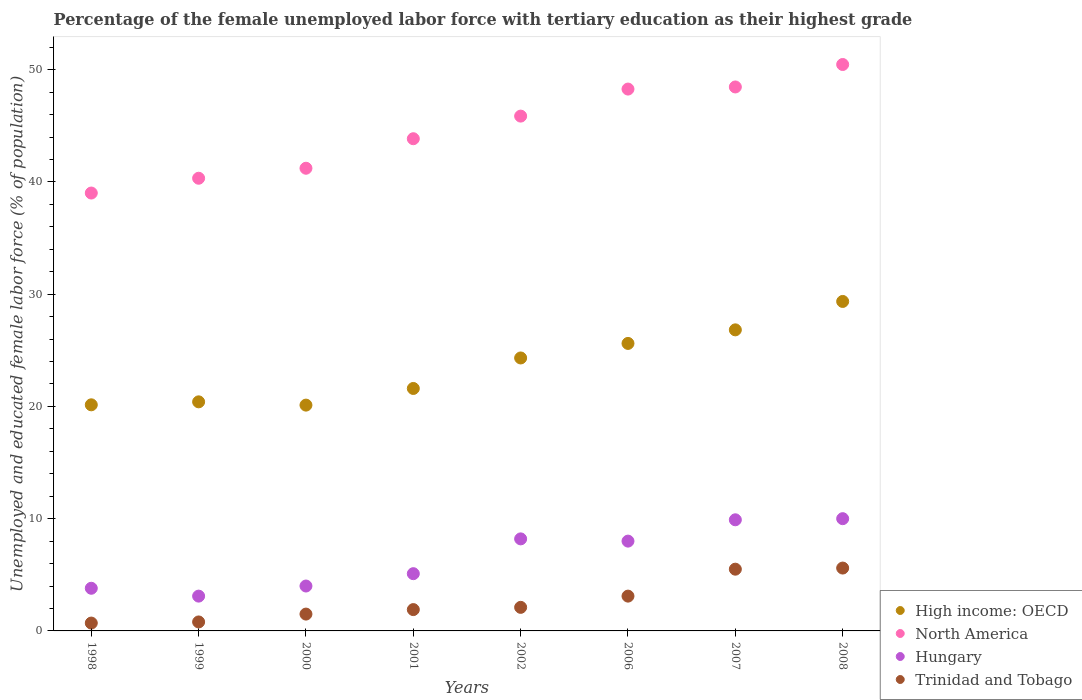How many different coloured dotlines are there?
Keep it short and to the point. 4. What is the percentage of the unemployed female labor force with tertiary education in High income: OECD in 2006?
Make the answer very short. 25.61. Across all years, what is the maximum percentage of the unemployed female labor force with tertiary education in High income: OECD?
Offer a terse response. 29.35. Across all years, what is the minimum percentage of the unemployed female labor force with tertiary education in Trinidad and Tobago?
Keep it short and to the point. 0.7. In which year was the percentage of the unemployed female labor force with tertiary education in Trinidad and Tobago maximum?
Provide a short and direct response. 2008. What is the total percentage of the unemployed female labor force with tertiary education in North America in the graph?
Your response must be concise. 357.46. What is the difference between the percentage of the unemployed female labor force with tertiary education in Trinidad and Tobago in 1998 and that in 2000?
Ensure brevity in your answer.  -0.8. What is the difference between the percentage of the unemployed female labor force with tertiary education in Hungary in 1999 and the percentage of the unemployed female labor force with tertiary education in High income: OECD in 2001?
Your answer should be very brief. -18.5. What is the average percentage of the unemployed female labor force with tertiary education in Trinidad and Tobago per year?
Provide a short and direct response. 2.65. In the year 2007, what is the difference between the percentage of the unemployed female labor force with tertiary education in Hungary and percentage of the unemployed female labor force with tertiary education in North America?
Your answer should be very brief. -38.56. In how many years, is the percentage of the unemployed female labor force with tertiary education in High income: OECD greater than 38 %?
Keep it short and to the point. 0. What is the ratio of the percentage of the unemployed female labor force with tertiary education in North America in 1999 to that in 2001?
Offer a terse response. 0.92. Is the percentage of the unemployed female labor force with tertiary education in North America in 2006 less than that in 2007?
Your answer should be very brief. Yes. What is the difference between the highest and the second highest percentage of the unemployed female labor force with tertiary education in Trinidad and Tobago?
Make the answer very short. 0.1. What is the difference between the highest and the lowest percentage of the unemployed female labor force with tertiary education in North America?
Offer a very short reply. 11.45. Is the sum of the percentage of the unemployed female labor force with tertiary education in Hungary in 2007 and 2008 greater than the maximum percentage of the unemployed female labor force with tertiary education in High income: OECD across all years?
Provide a succinct answer. No. Does the percentage of the unemployed female labor force with tertiary education in North America monotonically increase over the years?
Offer a terse response. Yes. Is the percentage of the unemployed female labor force with tertiary education in Trinidad and Tobago strictly less than the percentage of the unemployed female labor force with tertiary education in North America over the years?
Provide a succinct answer. Yes. What is the difference between two consecutive major ticks on the Y-axis?
Give a very brief answer. 10. Are the values on the major ticks of Y-axis written in scientific E-notation?
Your response must be concise. No. Does the graph contain grids?
Give a very brief answer. No. How many legend labels are there?
Ensure brevity in your answer.  4. What is the title of the graph?
Make the answer very short. Percentage of the female unemployed labor force with tertiary education as their highest grade. Does "Angola" appear as one of the legend labels in the graph?
Keep it short and to the point. No. What is the label or title of the X-axis?
Your response must be concise. Years. What is the label or title of the Y-axis?
Ensure brevity in your answer.  Unemployed and educated female labor force (% of population). What is the Unemployed and educated female labor force (% of population) of High income: OECD in 1998?
Provide a succinct answer. 20.14. What is the Unemployed and educated female labor force (% of population) of North America in 1998?
Make the answer very short. 39.01. What is the Unemployed and educated female labor force (% of population) in Hungary in 1998?
Provide a succinct answer. 3.8. What is the Unemployed and educated female labor force (% of population) in Trinidad and Tobago in 1998?
Give a very brief answer. 0.7. What is the Unemployed and educated female labor force (% of population) in High income: OECD in 1999?
Provide a succinct answer. 20.41. What is the Unemployed and educated female labor force (% of population) in North America in 1999?
Provide a short and direct response. 40.33. What is the Unemployed and educated female labor force (% of population) in Hungary in 1999?
Your answer should be compact. 3.1. What is the Unemployed and educated female labor force (% of population) of Trinidad and Tobago in 1999?
Your response must be concise. 0.8. What is the Unemployed and educated female labor force (% of population) of High income: OECD in 2000?
Offer a very short reply. 20.12. What is the Unemployed and educated female labor force (% of population) of North America in 2000?
Offer a terse response. 41.22. What is the Unemployed and educated female labor force (% of population) in High income: OECD in 2001?
Provide a short and direct response. 21.6. What is the Unemployed and educated female labor force (% of population) of North America in 2001?
Offer a very short reply. 43.85. What is the Unemployed and educated female labor force (% of population) of Hungary in 2001?
Provide a succinct answer. 5.1. What is the Unemployed and educated female labor force (% of population) of Trinidad and Tobago in 2001?
Offer a very short reply. 1.9. What is the Unemployed and educated female labor force (% of population) of High income: OECD in 2002?
Your answer should be compact. 24.32. What is the Unemployed and educated female labor force (% of population) in North America in 2002?
Offer a terse response. 45.86. What is the Unemployed and educated female labor force (% of population) in Hungary in 2002?
Give a very brief answer. 8.2. What is the Unemployed and educated female labor force (% of population) in Trinidad and Tobago in 2002?
Offer a terse response. 2.1. What is the Unemployed and educated female labor force (% of population) of High income: OECD in 2006?
Keep it short and to the point. 25.61. What is the Unemployed and educated female labor force (% of population) of North America in 2006?
Your answer should be compact. 48.27. What is the Unemployed and educated female labor force (% of population) in Trinidad and Tobago in 2006?
Provide a succinct answer. 3.1. What is the Unemployed and educated female labor force (% of population) in High income: OECD in 2007?
Your answer should be very brief. 26.82. What is the Unemployed and educated female labor force (% of population) of North America in 2007?
Your answer should be compact. 48.46. What is the Unemployed and educated female labor force (% of population) of Hungary in 2007?
Offer a very short reply. 9.9. What is the Unemployed and educated female labor force (% of population) in Trinidad and Tobago in 2007?
Your answer should be very brief. 5.5. What is the Unemployed and educated female labor force (% of population) in High income: OECD in 2008?
Give a very brief answer. 29.35. What is the Unemployed and educated female labor force (% of population) in North America in 2008?
Provide a succinct answer. 50.46. What is the Unemployed and educated female labor force (% of population) of Trinidad and Tobago in 2008?
Ensure brevity in your answer.  5.6. Across all years, what is the maximum Unemployed and educated female labor force (% of population) of High income: OECD?
Offer a very short reply. 29.35. Across all years, what is the maximum Unemployed and educated female labor force (% of population) in North America?
Make the answer very short. 50.46. Across all years, what is the maximum Unemployed and educated female labor force (% of population) in Hungary?
Provide a short and direct response. 10. Across all years, what is the maximum Unemployed and educated female labor force (% of population) of Trinidad and Tobago?
Offer a very short reply. 5.6. Across all years, what is the minimum Unemployed and educated female labor force (% of population) of High income: OECD?
Provide a short and direct response. 20.12. Across all years, what is the minimum Unemployed and educated female labor force (% of population) in North America?
Give a very brief answer. 39.01. Across all years, what is the minimum Unemployed and educated female labor force (% of population) of Hungary?
Make the answer very short. 3.1. Across all years, what is the minimum Unemployed and educated female labor force (% of population) of Trinidad and Tobago?
Offer a terse response. 0.7. What is the total Unemployed and educated female labor force (% of population) of High income: OECD in the graph?
Your answer should be compact. 188.37. What is the total Unemployed and educated female labor force (% of population) of North America in the graph?
Give a very brief answer. 357.46. What is the total Unemployed and educated female labor force (% of population) of Hungary in the graph?
Your answer should be very brief. 52.1. What is the total Unemployed and educated female labor force (% of population) of Trinidad and Tobago in the graph?
Ensure brevity in your answer.  21.2. What is the difference between the Unemployed and educated female labor force (% of population) in High income: OECD in 1998 and that in 1999?
Offer a terse response. -0.27. What is the difference between the Unemployed and educated female labor force (% of population) in North America in 1998 and that in 1999?
Give a very brief answer. -1.32. What is the difference between the Unemployed and educated female labor force (% of population) of Hungary in 1998 and that in 1999?
Provide a succinct answer. 0.7. What is the difference between the Unemployed and educated female labor force (% of population) of High income: OECD in 1998 and that in 2000?
Provide a short and direct response. 0.03. What is the difference between the Unemployed and educated female labor force (% of population) in North America in 1998 and that in 2000?
Ensure brevity in your answer.  -2.21. What is the difference between the Unemployed and educated female labor force (% of population) of Trinidad and Tobago in 1998 and that in 2000?
Offer a very short reply. -0.8. What is the difference between the Unemployed and educated female labor force (% of population) in High income: OECD in 1998 and that in 2001?
Ensure brevity in your answer.  -1.46. What is the difference between the Unemployed and educated female labor force (% of population) of North America in 1998 and that in 2001?
Provide a short and direct response. -4.84. What is the difference between the Unemployed and educated female labor force (% of population) in Hungary in 1998 and that in 2001?
Your answer should be compact. -1.3. What is the difference between the Unemployed and educated female labor force (% of population) of High income: OECD in 1998 and that in 2002?
Your response must be concise. -4.17. What is the difference between the Unemployed and educated female labor force (% of population) of North America in 1998 and that in 2002?
Make the answer very short. -6.85. What is the difference between the Unemployed and educated female labor force (% of population) of Hungary in 1998 and that in 2002?
Offer a terse response. -4.4. What is the difference between the Unemployed and educated female labor force (% of population) in Trinidad and Tobago in 1998 and that in 2002?
Offer a very short reply. -1.4. What is the difference between the Unemployed and educated female labor force (% of population) of High income: OECD in 1998 and that in 2006?
Your answer should be compact. -5.47. What is the difference between the Unemployed and educated female labor force (% of population) in North America in 1998 and that in 2006?
Offer a terse response. -9.26. What is the difference between the Unemployed and educated female labor force (% of population) in High income: OECD in 1998 and that in 2007?
Keep it short and to the point. -6.68. What is the difference between the Unemployed and educated female labor force (% of population) of North America in 1998 and that in 2007?
Give a very brief answer. -9.45. What is the difference between the Unemployed and educated female labor force (% of population) of Trinidad and Tobago in 1998 and that in 2007?
Provide a succinct answer. -4.8. What is the difference between the Unemployed and educated female labor force (% of population) of High income: OECD in 1998 and that in 2008?
Make the answer very short. -9.21. What is the difference between the Unemployed and educated female labor force (% of population) of North America in 1998 and that in 2008?
Your answer should be compact. -11.45. What is the difference between the Unemployed and educated female labor force (% of population) in High income: OECD in 1999 and that in 2000?
Your answer should be very brief. 0.29. What is the difference between the Unemployed and educated female labor force (% of population) of North America in 1999 and that in 2000?
Provide a succinct answer. -0.89. What is the difference between the Unemployed and educated female labor force (% of population) in Hungary in 1999 and that in 2000?
Provide a succinct answer. -0.9. What is the difference between the Unemployed and educated female labor force (% of population) in High income: OECD in 1999 and that in 2001?
Provide a succinct answer. -1.19. What is the difference between the Unemployed and educated female labor force (% of population) in North America in 1999 and that in 2001?
Provide a short and direct response. -3.52. What is the difference between the Unemployed and educated female labor force (% of population) of Trinidad and Tobago in 1999 and that in 2001?
Make the answer very short. -1.1. What is the difference between the Unemployed and educated female labor force (% of population) in High income: OECD in 1999 and that in 2002?
Your response must be concise. -3.91. What is the difference between the Unemployed and educated female labor force (% of population) of North America in 1999 and that in 2002?
Offer a terse response. -5.54. What is the difference between the Unemployed and educated female labor force (% of population) of Trinidad and Tobago in 1999 and that in 2002?
Provide a short and direct response. -1.3. What is the difference between the Unemployed and educated female labor force (% of population) of High income: OECD in 1999 and that in 2006?
Provide a succinct answer. -5.2. What is the difference between the Unemployed and educated female labor force (% of population) in North America in 1999 and that in 2006?
Make the answer very short. -7.94. What is the difference between the Unemployed and educated female labor force (% of population) in High income: OECD in 1999 and that in 2007?
Offer a very short reply. -6.41. What is the difference between the Unemployed and educated female labor force (% of population) in North America in 1999 and that in 2007?
Make the answer very short. -8.13. What is the difference between the Unemployed and educated female labor force (% of population) in Hungary in 1999 and that in 2007?
Make the answer very short. -6.8. What is the difference between the Unemployed and educated female labor force (% of population) of Trinidad and Tobago in 1999 and that in 2007?
Provide a succinct answer. -4.7. What is the difference between the Unemployed and educated female labor force (% of population) in High income: OECD in 1999 and that in 2008?
Your response must be concise. -8.94. What is the difference between the Unemployed and educated female labor force (% of population) of North America in 1999 and that in 2008?
Offer a terse response. -10.13. What is the difference between the Unemployed and educated female labor force (% of population) of Hungary in 1999 and that in 2008?
Give a very brief answer. -6.9. What is the difference between the Unemployed and educated female labor force (% of population) of High income: OECD in 2000 and that in 2001?
Your answer should be very brief. -1.48. What is the difference between the Unemployed and educated female labor force (% of population) of North America in 2000 and that in 2001?
Keep it short and to the point. -2.63. What is the difference between the Unemployed and educated female labor force (% of population) of Hungary in 2000 and that in 2001?
Provide a succinct answer. -1.1. What is the difference between the Unemployed and educated female labor force (% of population) of Trinidad and Tobago in 2000 and that in 2001?
Provide a short and direct response. -0.4. What is the difference between the Unemployed and educated female labor force (% of population) of High income: OECD in 2000 and that in 2002?
Your response must be concise. -4.2. What is the difference between the Unemployed and educated female labor force (% of population) of North America in 2000 and that in 2002?
Your response must be concise. -4.65. What is the difference between the Unemployed and educated female labor force (% of population) of High income: OECD in 2000 and that in 2006?
Keep it short and to the point. -5.5. What is the difference between the Unemployed and educated female labor force (% of population) in North America in 2000 and that in 2006?
Give a very brief answer. -7.05. What is the difference between the Unemployed and educated female labor force (% of population) of Hungary in 2000 and that in 2006?
Provide a short and direct response. -4. What is the difference between the Unemployed and educated female labor force (% of population) of Trinidad and Tobago in 2000 and that in 2006?
Provide a short and direct response. -1.6. What is the difference between the Unemployed and educated female labor force (% of population) of High income: OECD in 2000 and that in 2007?
Offer a terse response. -6.71. What is the difference between the Unemployed and educated female labor force (% of population) in North America in 2000 and that in 2007?
Provide a succinct answer. -7.24. What is the difference between the Unemployed and educated female labor force (% of population) of Hungary in 2000 and that in 2007?
Make the answer very short. -5.9. What is the difference between the Unemployed and educated female labor force (% of population) of Trinidad and Tobago in 2000 and that in 2007?
Offer a terse response. -4. What is the difference between the Unemployed and educated female labor force (% of population) in High income: OECD in 2000 and that in 2008?
Give a very brief answer. -9.24. What is the difference between the Unemployed and educated female labor force (% of population) in North America in 2000 and that in 2008?
Keep it short and to the point. -9.24. What is the difference between the Unemployed and educated female labor force (% of population) in Hungary in 2000 and that in 2008?
Keep it short and to the point. -6. What is the difference between the Unemployed and educated female labor force (% of population) of High income: OECD in 2001 and that in 2002?
Keep it short and to the point. -2.72. What is the difference between the Unemployed and educated female labor force (% of population) in North America in 2001 and that in 2002?
Provide a short and direct response. -2.01. What is the difference between the Unemployed and educated female labor force (% of population) of Hungary in 2001 and that in 2002?
Your answer should be very brief. -3.1. What is the difference between the Unemployed and educated female labor force (% of population) in High income: OECD in 2001 and that in 2006?
Offer a terse response. -4.01. What is the difference between the Unemployed and educated female labor force (% of population) of North America in 2001 and that in 2006?
Keep it short and to the point. -4.42. What is the difference between the Unemployed and educated female labor force (% of population) in Trinidad and Tobago in 2001 and that in 2006?
Give a very brief answer. -1.2. What is the difference between the Unemployed and educated female labor force (% of population) of High income: OECD in 2001 and that in 2007?
Provide a short and direct response. -5.22. What is the difference between the Unemployed and educated female labor force (% of population) of North America in 2001 and that in 2007?
Keep it short and to the point. -4.61. What is the difference between the Unemployed and educated female labor force (% of population) in Hungary in 2001 and that in 2007?
Keep it short and to the point. -4.8. What is the difference between the Unemployed and educated female labor force (% of population) in High income: OECD in 2001 and that in 2008?
Give a very brief answer. -7.75. What is the difference between the Unemployed and educated female labor force (% of population) in North America in 2001 and that in 2008?
Your answer should be compact. -6.61. What is the difference between the Unemployed and educated female labor force (% of population) in Hungary in 2001 and that in 2008?
Your answer should be very brief. -4.9. What is the difference between the Unemployed and educated female labor force (% of population) of Trinidad and Tobago in 2001 and that in 2008?
Provide a short and direct response. -3.7. What is the difference between the Unemployed and educated female labor force (% of population) of High income: OECD in 2002 and that in 2006?
Give a very brief answer. -1.3. What is the difference between the Unemployed and educated female labor force (% of population) of North America in 2002 and that in 2006?
Provide a short and direct response. -2.41. What is the difference between the Unemployed and educated female labor force (% of population) in Trinidad and Tobago in 2002 and that in 2006?
Offer a very short reply. -1. What is the difference between the Unemployed and educated female labor force (% of population) of High income: OECD in 2002 and that in 2007?
Make the answer very short. -2.5. What is the difference between the Unemployed and educated female labor force (% of population) in North America in 2002 and that in 2007?
Offer a terse response. -2.6. What is the difference between the Unemployed and educated female labor force (% of population) in Hungary in 2002 and that in 2007?
Your answer should be very brief. -1.7. What is the difference between the Unemployed and educated female labor force (% of population) in High income: OECD in 2002 and that in 2008?
Keep it short and to the point. -5.03. What is the difference between the Unemployed and educated female labor force (% of population) of North America in 2002 and that in 2008?
Keep it short and to the point. -4.6. What is the difference between the Unemployed and educated female labor force (% of population) in Hungary in 2002 and that in 2008?
Keep it short and to the point. -1.8. What is the difference between the Unemployed and educated female labor force (% of population) in Trinidad and Tobago in 2002 and that in 2008?
Offer a terse response. -3.5. What is the difference between the Unemployed and educated female labor force (% of population) of High income: OECD in 2006 and that in 2007?
Ensure brevity in your answer.  -1.21. What is the difference between the Unemployed and educated female labor force (% of population) in North America in 2006 and that in 2007?
Your response must be concise. -0.19. What is the difference between the Unemployed and educated female labor force (% of population) in Hungary in 2006 and that in 2007?
Your response must be concise. -1.9. What is the difference between the Unemployed and educated female labor force (% of population) of High income: OECD in 2006 and that in 2008?
Make the answer very short. -3.74. What is the difference between the Unemployed and educated female labor force (% of population) of North America in 2006 and that in 2008?
Ensure brevity in your answer.  -2.19. What is the difference between the Unemployed and educated female labor force (% of population) of Hungary in 2006 and that in 2008?
Give a very brief answer. -2. What is the difference between the Unemployed and educated female labor force (% of population) in Trinidad and Tobago in 2006 and that in 2008?
Offer a very short reply. -2.5. What is the difference between the Unemployed and educated female labor force (% of population) of High income: OECD in 2007 and that in 2008?
Ensure brevity in your answer.  -2.53. What is the difference between the Unemployed and educated female labor force (% of population) of North America in 2007 and that in 2008?
Keep it short and to the point. -2. What is the difference between the Unemployed and educated female labor force (% of population) in Trinidad and Tobago in 2007 and that in 2008?
Provide a short and direct response. -0.1. What is the difference between the Unemployed and educated female labor force (% of population) in High income: OECD in 1998 and the Unemployed and educated female labor force (% of population) in North America in 1999?
Give a very brief answer. -20.18. What is the difference between the Unemployed and educated female labor force (% of population) of High income: OECD in 1998 and the Unemployed and educated female labor force (% of population) of Hungary in 1999?
Your answer should be compact. 17.04. What is the difference between the Unemployed and educated female labor force (% of population) in High income: OECD in 1998 and the Unemployed and educated female labor force (% of population) in Trinidad and Tobago in 1999?
Provide a short and direct response. 19.34. What is the difference between the Unemployed and educated female labor force (% of population) in North America in 1998 and the Unemployed and educated female labor force (% of population) in Hungary in 1999?
Offer a terse response. 35.91. What is the difference between the Unemployed and educated female labor force (% of population) in North America in 1998 and the Unemployed and educated female labor force (% of population) in Trinidad and Tobago in 1999?
Give a very brief answer. 38.21. What is the difference between the Unemployed and educated female labor force (% of population) of High income: OECD in 1998 and the Unemployed and educated female labor force (% of population) of North America in 2000?
Offer a terse response. -21.08. What is the difference between the Unemployed and educated female labor force (% of population) of High income: OECD in 1998 and the Unemployed and educated female labor force (% of population) of Hungary in 2000?
Make the answer very short. 16.14. What is the difference between the Unemployed and educated female labor force (% of population) of High income: OECD in 1998 and the Unemployed and educated female labor force (% of population) of Trinidad and Tobago in 2000?
Offer a very short reply. 18.64. What is the difference between the Unemployed and educated female labor force (% of population) in North America in 1998 and the Unemployed and educated female labor force (% of population) in Hungary in 2000?
Keep it short and to the point. 35.01. What is the difference between the Unemployed and educated female labor force (% of population) in North America in 1998 and the Unemployed and educated female labor force (% of population) in Trinidad and Tobago in 2000?
Provide a succinct answer. 37.51. What is the difference between the Unemployed and educated female labor force (% of population) of Hungary in 1998 and the Unemployed and educated female labor force (% of population) of Trinidad and Tobago in 2000?
Ensure brevity in your answer.  2.3. What is the difference between the Unemployed and educated female labor force (% of population) in High income: OECD in 1998 and the Unemployed and educated female labor force (% of population) in North America in 2001?
Your answer should be very brief. -23.71. What is the difference between the Unemployed and educated female labor force (% of population) of High income: OECD in 1998 and the Unemployed and educated female labor force (% of population) of Hungary in 2001?
Give a very brief answer. 15.04. What is the difference between the Unemployed and educated female labor force (% of population) in High income: OECD in 1998 and the Unemployed and educated female labor force (% of population) in Trinidad and Tobago in 2001?
Offer a very short reply. 18.24. What is the difference between the Unemployed and educated female labor force (% of population) in North America in 1998 and the Unemployed and educated female labor force (% of population) in Hungary in 2001?
Provide a short and direct response. 33.91. What is the difference between the Unemployed and educated female labor force (% of population) of North America in 1998 and the Unemployed and educated female labor force (% of population) of Trinidad and Tobago in 2001?
Offer a very short reply. 37.11. What is the difference between the Unemployed and educated female labor force (% of population) of High income: OECD in 1998 and the Unemployed and educated female labor force (% of population) of North America in 2002?
Keep it short and to the point. -25.72. What is the difference between the Unemployed and educated female labor force (% of population) of High income: OECD in 1998 and the Unemployed and educated female labor force (% of population) of Hungary in 2002?
Provide a succinct answer. 11.94. What is the difference between the Unemployed and educated female labor force (% of population) of High income: OECD in 1998 and the Unemployed and educated female labor force (% of population) of Trinidad and Tobago in 2002?
Provide a short and direct response. 18.04. What is the difference between the Unemployed and educated female labor force (% of population) of North America in 1998 and the Unemployed and educated female labor force (% of population) of Hungary in 2002?
Provide a short and direct response. 30.81. What is the difference between the Unemployed and educated female labor force (% of population) of North America in 1998 and the Unemployed and educated female labor force (% of population) of Trinidad and Tobago in 2002?
Provide a succinct answer. 36.91. What is the difference between the Unemployed and educated female labor force (% of population) of High income: OECD in 1998 and the Unemployed and educated female labor force (% of population) of North America in 2006?
Keep it short and to the point. -28.13. What is the difference between the Unemployed and educated female labor force (% of population) of High income: OECD in 1998 and the Unemployed and educated female labor force (% of population) of Hungary in 2006?
Give a very brief answer. 12.14. What is the difference between the Unemployed and educated female labor force (% of population) in High income: OECD in 1998 and the Unemployed and educated female labor force (% of population) in Trinidad and Tobago in 2006?
Ensure brevity in your answer.  17.04. What is the difference between the Unemployed and educated female labor force (% of population) in North America in 1998 and the Unemployed and educated female labor force (% of population) in Hungary in 2006?
Provide a short and direct response. 31.01. What is the difference between the Unemployed and educated female labor force (% of population) of North America in 1998 and the Unemployed and educated female labor force (% of population) of Trinidad and Tobago in 2006?
Make the answer very short. 35.91. What is the difference between the Unemployed and educated female labor force (% of population) in Hungary in 1998 and the Unemployed and educated female labor force (% of population) in Trinidad and Tobago in 2006?
Make the answer very short. 0.7. What is the difference between the Unemployed and educated female labor force (% of population) in High income: OECD in 1998 and the Unemployed and educated female labor force (% of population) in North America in 2007?
Ensure brevity in your answer.  -28.32. What is the difference between the Unemployed and educated female labor force (% of population) in High income: OECD in 1998 and the Unemployed and educated female labor force (% of population) in Hungary in 2007?
Make the answer very short. 10.24. What is the difference between the Unemployed and educated female labor force (% of population) of High income: OECD in 1998 and the Unemployed and educated female labor force (% of population) of Trinidad and Tobago in 2007?
Provide a short and direct response. 14.64. What is the difference between the Unemployed and educated female labor force (% of population) of North America in 1998 and the Unemployed and educated female labor force (% of population) of Hungary in 2007?
Ensure brevity in your answer.  29.11. What is the difference between the Unemployed and educated female labor force (% of population) of North America in 1998 and the Unemployed and educated female labor force (% of population) of Trinidad and Tobago in 2007?
Provide a short and direct response. 33.51. What is the difference between the Unemployed and educated female labor force (% of population) of Hungary in 1998 and the Unemployed and educated female labor force (% of population) of Trinidad and Tobago in 2007?
Keep it short and to the point. -1.7. What is the difference between the Unemployed and educated female labor force (% of population) of High income: OECD in 1998 and the Unemployed and educated female labor force (% of population) of North America in 2008?
Your answer should be compact. -30.32. What is the difference between the Unemployed and educated female labor force (% of population) in High income: OECD in 1998 and the Unemployed and educated female labor force (% of population) in Hungary in 2008?
Give a very brief answer. 10.14. What is the difference between the Unemployed and educated female labor force (% of population) of High income: OECD in 1998 and the Unemployed and educated female labor force (% of population) of Trinidad and Tobago in 2008?
Offer a terse response. 14.54. What is the difference between the Unemployed and educated female labor force (% of population) in North America in 1998 and the Unemployed and educated female labor force (% of population) in Hungary in 2008?
Make the answer very short. 29.01. What is the difference between the Unemployed and educated female labor force (% of population) in North America in 1998 and the Unemployed and educated female labor force (% of population) in Trinidad and Tobago in 2008?
Keep it short and to the point. 33.41. What is the difference between the Unemployed and educated female labor force (% of population) in High income: OECD in 1999 and the Unemployed and educated female labor force (% of population) in North America in 2000?
Keep it short and to the point. -20.81. What is the difference between the Unemployed and educated female labor force (% of population) in High income: OECD in 1999 and the Unemployed and educated female labor force (% of population) in Hungary in 2000?
Your answer should be very brief. 16.41. What is the difference between the Unemployed and educated female labor force (% of population) of High income: OECD in 1999 and the Unemployed and educated female labor force (% of population) of Trinidad and Tobago in 2000?
Ensure brevity in your answer.  18.91. What is the difference between the Unemployed and educated female labor force (% of population) in North America in 1999 and the Unemployed and educated female labor force (% of population) in Hungary in 2000?
Keep it short and to the point. 36.33. What is the difference between the Unemployed and educated female labor force (% of population) of North America in 1999 and the Unemployed and educated female labor force (% of population) of Trinidad and Tobago in 2000?
Your answer should be very brief. 38.83. What is the difference between the Unemployed and educated female labor force (% of population) of Hungary in 1999 and the Unemployed and educated female labor force (% of population) of Trinidad and Tobago in 2000?
Give a very brief answer. 1.6. What is the difference between the Unemployed and educated female labor force (% of population) of High income: OECD in 1999 and the Unemployed and educated female labor force (% of population) of North America in 2001?
Keep it short and to the point. -23.44. What is the difference between the Unemployed and educated female labor force (% of population) of High income: OECD in 1999 and the Unemployed and educated female labor force (% of population) of Hungary in 2001?
Keep it short and to the point. 15.31. What is the difference between the Unemployed and educated female labor force (% of population) in High income: OECD in 1999 and the Unemployed and educated female labor force (% of population) in Trinidad and Tobago in 2001?
Your answer should be compact. 18.51. What is the difference between the Unemployed and educated female labor force (% of population) in North America in 1999 and the Unemployed and educated female labor force (% of population) in Hungary in 2001?
Provide a short and direct response. 35.23. What is the difference between the Unemployed and educated female labor force (% of population) of North America in 1999 and the Unemployed and educated female labor force (% of population) of Trinidad and Tobago in 2001?
Keep it short and to the point. 38.43. What is the difference between the Unemployed and educated female labor force (% of population) of High income: OECD in 1999 and the Unemployed and educated female labor force (% of population) of North America in 2002?
Provide a short and direct response. -25.46. What is the difference between the Unemployed and educated female labor force (% of population) in High income: OECD in 1999 and the Unemployed and educated female labor force (% of population) in Hungary in 2002?
Offer a very short reply. 12.21. What is the difference between the Unemployed and educated female labor force (% of population) of High income: OECD in 1999 and the Unemployed and educated female labor force (% of population) of Trinidad and Tobago in 2002?
Your answer should be very brief. 18.31. What is the difference between the Unemployed and educated female labor force (% of population) in North America in 1999 and the Unemployed and educated female labor force (% of population) in Hungary in 2002?
Your answer should be very brief. 32.13. What is the difference between the Unemployed and educated female labor force (% of population) of North America in 1999 and the Unemployed and educated female labor force (% of population) of Trinidad and Tobago in 2002?
Your response must be concise. 38.23. What is the difference between the Unemployed and educated female labor force (% of population) in High income: OECD in 1999 and the Unemployed and educated female labor force (% of population) in North America in 2006?
Provide a succinct answer. -27.86. What is the difference between the Unemployed and educated female labor force (% of population) in High income: OECD in 1999 and the Unemployed and educated female labor force (% of population) in Hungary in 2006?
Ensure brevity in your answer.  12.41. What is the difference between the Unemployed and educated female labor force (% of population) in High income: OECD in 1999 and the Unemployed and educated female labor force (% of population) in Trinidad and Tobago in 2006?
Your response must be concise. 17.31. What is the difference between the Unemployed and educated female labor force (% of population) of North America in 1999 and the Unemployed and educated female labor force (% of population) of Hungary in 2006?
Keep it short and to the point. 32.33. What is the difference between the Unemployed and educated female labor force (% of population) in North America in 1999 and the Unemployed and educated female labor force (% of population) in Trinidad and Tobago in 2006?
Offer a terse response. 37.23. What is the difference between the Unemployed and educated female labor force (% of population) in High income: OECD in 1999 and the Unemployed and educated female labor force (% of population) in North America in 2007?
Offer a terse response. -28.05. What is the difference between the Unemployed and educated female labor force (% of population) of High income: OECD in 1999 and the Unemployed and educated female labor force (% of population) of Hungary in 2007?
Ensure brevity in your answer.  10.51. What is the difference between the Unemployed and educated female labor force (% of population) in High income: OECD in 1999 and the Unemployed and educated female labor force (% of population) in Trinidad and Tobago in 2007?
Your response must be concise. 14.91. What is the difference between the Unemployed and educated female labor force (% of population) of North America in 1999 and the Unemployed and educated female labor force (% of population) of Hungary in 2007?
Make the answer very short. 30.43. What is the difference between the Unemployed and educated female labor force (% of population) in North America in 1999 and the Unemployed and educated female labor force (% of population) in Trinidad and Tobago in 2007?
Offer a very short reply. 34.83. What is the difference between the Unemployed and educated female labor force (% of population) of High income: OECD in 1999 and the Unemployed and educated female labor force (% of population) of North America in 2008?
Keep it short and to the point. -30.05. What is the difference between the Unemployed and educated female labor force (% of population) in High income: OECD in 1999 and the Unemployed and educated female labor force (% of population) in Hungary in 2008?
Your response must be concise. 10.41. What is the difference between the Unemployed and educated female labor force (% of population) in High income: OECD in 1999 and the Unemployed and educated female labor force (% of population) in Trinidad and Tobago in 2008?
Offer a terse response. 14.81. What is the difference between the Unemployed and educated female labor force (% of population) of North America in 1999 and the Unemployed and educated female labor force (% of population) of Hungary in 2008?
Provide a succinct answer. 30.33. What is the difference between the Unemployed and educated female labor force (% of population) of North America in 1999 and the Unemployed and educated female labor force (% of population) of Trinidad and Tobago in 2008?
Offer a terse response. 34.73. What is the difference between the Unemployed and educated female labor force (% of population) in Hungary in 1999 and the Unemployed and educated female labor force (% of population) in Trinidad and Tobago in 2008?
Your answer should be compact. -2.5. What is the difference between the Unemployed and educated female labor force (% of population) in High income: OECD in 2000 and the Unemployed and educated female labor force (% of population) in North America in 2001?
Ensure brevity in your answer.  -23.73. What is the difference between the Unemployed and educated female labor force (% of population) in High income: OECD in 2000 and the Unemployed and educated female labor force (% of population) in Hungary in 2001?
Your response must be concise. 15.02. What is the difference between the Unemployed and educated female labor force (% of population) of High income: OECD in 2000 and the Unemployed and educated female labor force (% of population) of Trinidad and Tobago in 2001?
Give a very brief answer. 18.22. What is the difference between the Unemployed and educated female labor force (% of population) of North America in 2000 and the Unemployed and educated female labor force (% of population) of Hungary in 2001?
Your response must be concise. 36.12. What is the difference between the Unemployed and educated female labor force (% of population) of North America in 2000 and the Unemployed and educated female labor force (% of population) of Trinidad and Tobago in 2001?
Your answer should be compact. 39.32. What is the difference between the Unemployed and educated female labor force (% of population) of High income: OECD in 2000 and the Unemployed and educated female labor force (% of population) of North America in 2002?
Ensure brevity in your answer.  -25.75. What is the difference between the Unemployed and educated female labor force (% of population) of High income: OECD in 2000 and the Unemployed and educated female labor force (% of population) of Hungary in 2002?
Your answer should be very brief. 11.92. What is the difference between the Unemployed and educated female labor force (% of population) in High income: OECD in 2000 and the Unemployed and educated female labor force (% of population) in Trinidad and Tobago in 2002?
Offer a terse response. 18.02. What is the difference between the Unemployed and educated female labor force (% of population) of North America in 2000 and the Unemployed and educated female labor force (% of population) of Hungary in 2002?
Your answer should be very brief. 33.02. What is the difference between the Unemployed and educated female labor force (% of population) of North America in 2000 and the Unemployed and educated female labor force (% of population) of Trinidad and Tobago in 2002?
Your answer should be compact. 39.12. What is the difference between the Unemployed and educated female labor force (% of population) of High income: OECD in 2000 and the Unemployed and educated female labor force (% of population) of North America in 2006?
Provide a short and direct response. -28.16. What is the difference between the Unemployed and educated female labor force (% of population) of High income: OECD in 2000 and the Unemployed and educated female labor force (% of population) of Hungary in 2006?
Keep it short and to the point. 12.12. What is the difference between the Unemployed and educated female labor force (% of population) in High income: OECD in 2000 and the Unemployed and educated female labor force (% of population) in Trinidad and Tobago in 2006?
Offer a very short reply. 17.02. What is the difference between the Unemployed and educated female labor force (% of population) of North America in 2000 and the Unemployed and educated female labor force (% of population) of Hungary in 2006?
Provide a succinct answer. 33.22. What is the difference between the Unemployed and educated female labor force (% of population) of North America in 2000 and the Unemployed and educated female labor force (% of population) of Trinidad and Tobago in 2006?
Your answer should be very brief. 38.12. What is the difference between the Unemployed and educated female labor force (% of population) of High income: OECD in 2000 and the Unemployed and educated female labor force (% of population) of North America in 2007?
Give a very brief answer. -28.34. What is the difference between the Unemployed and educated female labor force (% of population) in High income: OECD in 2000 and the Unemployed and educated female labor force (% of population) in Hungary in 2007?
Your answer should be very brief. 10.22. What is the difference between the Unemployed and educated female labor force (% of population) of High income: OECD in 2000 and the Unemployed and educated female labor force (% of population) of Trinidad and Tobago in 2007?
Your answer should be compact. 14.62. What is the difference between the Unemployed and educated female labor force (% of population) in North America in 2000 and the Unemployed and educated female labor force (% of population) in Hungary in 2007?
Your answer should be very brief. 31.32. What is the difference between the Unemployed and educated female labor force (% of population) of North America in 2000 and the Unemployed and educated female labor force (% of population) of Trinidad and Tobago in 2007?
Keep it short and to the point. 35.72. What is the difference between the Unemployed and educated female labor force (% of population) of High income: OECD in 2000 and the Unemployed and educated female labor force (% of population) of North America in 2008?
Your answer should be compact. -30.34. What is the difference between the Unemployed and educated female labor force (% of population) of High income: OECD in 2000 and the Unemployed and educated female labor force (% of population) of Hungary in 2008?
Provide a short and direct response. 10.12. What is the difference between the Unemployed and educated female labor force (% of population) of High income: OECD in 2000 and the Unemployed and educated female labor force (% of population) of Trinidad and Tobago in 2008?
Give a very brief answer. 14.52. What is the difference between the Unemployed and educated female labor force (% of population) of North America in 2000 and the Unemployed and educated female labor force (% of population) of Hungary in 2008?
Your answer should be very brief. 31.22. What is the difference between the Unemployed and educated female labor force (% of population) in North America in 2000 and the Unemployed and educated female labor force (% of population) in Trinidad and Tobago in 2008?
Your answer should be compact. 35.62. What is the difference between the Unemployed and educated female labor force (% of population) in High income: OECD in 2001 and the Unemployed and educated female labor force (% of population) in North America in 2002?
Your answer should be compact. -24.26. What is the difference between the Unemployed and educated female labor force (% of population) of High income: OECD in 2001 and the Unemployed and educated female labor force (% of population) of Hungary in 2002?
Your answer should be very brief. 13.4. What is the difference between the Unemployed and educated female labor force (% of population) of High income: OECD in 2001 and the Unemployed and educated female labor force (% of population) of Trinidad and Tobago in 2002?
Keep it short and to the point. 19.5. What is the difference between the Unemployed and educated female labor force (% of population) in North America in 2001 and the Unemployed and educated female labor force (% of population) in Hungary in 2002?
Give a very brief answer. 35.65. What is the difference between the Unemployed and educated female labor force (% of population) in North America in 2001 and the Unemployed and educated female labor force (% of population) in Trinidad and Tobago in 2002?
Your response must be concise. 41.75. What is the difference between the Unemployed and educated female labor force (% of population) in Hungary in 2001 and the Unemployed and educated female labor force (% of population) in Trinidad and Tobago in 2002?
Keep it short and to the point. 3. What is the difference between the Unemployed and educated female labor force (% of population) of High income: OECD in 2001 and the Unemployed and educated female labor force (% of population) of North America in 2006?
Give a very brief answer. -26.67. What is the difference between the Unemployed and educated female labor force (% of population) of High income: OECD in 2001 and the Unemployed and educated female labor force (% of population) of Hungary in 2006?
Offer a terse response. 13.6. What is the difference between the Unemployed and educated female labor force (% of population) in High income: OECD in 2001 and the Unemployed and educated female labor force (% of population) in Trinidad and Tobago in 2006?
Your answer should be compact. 18.5. What is the difference between the Unemployed and educated female labor force (% of population) of North America in 2001 and the Unemployed and educated female labor force (% of population) of Hungary in 2006?
Provide a succinct answer. 35.85. What is the difference between the Unemployed and educated female labor force (% of population) of North America in 2001 and the Unemployed and educated female labor force (% of population) of Trinidad and Tobago in 2006?
Keep it short and to the point. 40.75. What is the difference between the Unemployed and educated female labor force (% of population) of High income: OECD in 2001 and the Unemployed and educated female labor force (% of population) of North America in 2007?
Offer a very short reply. -26.86. What is the difference between the Unemployed and educated female labor force (% of population) of High income: OECD in 2001 and the Unemployed and educated female labor force (% of population) of Hungary in 2007?
Your response must be concise. 11.7. What is the difference between the Unemployed and educated female labor force (% of population) of High income: OECD in 2001 and the Unemployed and educated female labor force (% of population) of Trinidad and Tobago in 2007?
Keep it short and to the point. 16.1. What is the difference between the Unemployed and educated female labor force (% of population) in North America in 2001 and the Unemployed and educated female labor force (% of population) in Hungary in 2007?
Give a very brief answer. 33.95. What is the difference between the Unemployed and educated female labor force (% of population) of North America in 2001 and the Unemployed and educated female labor force (% of population) of Trinidad and Tobago in 2007?
Offer a terse response. 38.35. What is the difference between the Unemployed and educated female labor force (% of population) of Hungary in 2001 and the Unemployed and educated female labor force (% of population) of Trinidad and Tobago in 2007?
Offer a terse response. -0.4. What is the difference between the Unemployed and educated female labor force (% of population) in High income: OECD in 2001 and the Unemployed and educated female labor force (% of population) in North America in 2008?
Make the answer very short. -28.86. What is the difference between the Unemployed and educated female labor force (% of population) in High income: OECD in 2001 and the Unemployed and educated female labor force (% of population) in Hungary in 2008?
Your response must be concise. 11.6. What is the difference between the Unemployed and educated female labor force (% of population) in High income: OECD in 2001 and the Unemployed and educated female labor force (% of population) in Trinidad and Tobago in 2008?
Your answer should be very brief. 16. What is the difference between the Unemployed and educated female labor force (% of population) of North America in 2001 and the Unemployed and educated female labor force (% of population) of Hungary in 2008?
Make the answer very short. 33.85. What is the difference between the Unemployed and educated female labor force (% of population) of North America in 2001 and the Unemployed and educated female labor force (% of population) of Trinidad and Tobago in 2008?
Your response must be concise. 38.25. What is the difference between the Unemployed and educated female labor force (% of population) in High income: OECD in 2002 and the Unemployed and educated female labor force (% of population) in North America in 2006?
Your answer should be very brief. -23.95. What is the difference between the Unemployed and educated female labor force (% of population) of High income: OECD in 2002 and the Unemployed and educated female labor force (% of population) of Hungary in 2006?
Provide a succinct answer. 16.32. What is the difference between the Unemployed and educated female labor force (% of population) of High income: OECD in 2002 and the Unemployed and educated female labor force (% of population) of Trinidad and Tobago in 2006?
Offer a very short reply. 21.22. What is the difference between the Unemployed and educated female labor force (% of population) in North America in 2002 and the Unemployed and educated female labor force (% of population) in Hungary in 2006?
Provide a succinct answer. 37.86. What is the difference between the Unemployed and educated female labor force (% of population) in North America in 2002 and the Unemployed and educated female labor force (% of population) in Trinidad and Tobago in 2006?
Ensure brevity in your answer.  42.76. What is the difference between the Unemployed and educated female labor force (% of population) of High income: OECD in 2002 and the Unemployed and educated female labor force (% of population) of North America in 2007?
Keep it short and to the point. -24.14. What is the difference between the Unemployed and educated female labor force (% of population) of High income: OECD in 2002 and the Unemployed and educated female labor force (% of population) of Hungary in 2007?
Give a very brief answer. 14.42. What is the difference between the Unemployed and educated female labor force (% of population) in High income: OECD in 2002 and the Unemployed and educated female labor force (% of population) in Trinidad and Tobago in 2007?
Your answer should be very brief. 18.82. What is the difference between the Unemployed and educated female labor force (% of population) of North America in 2002 and the Unemployed and educated female labor force (% of population) of Hungary in 2007?
Provide a short and direct response. 35.96. What is the difference between the Unemployed and educated female labor force (% of population) of North America in 2002 and the Unemployed and educated female labor force (% of population) of Trinidad and Tobago in 2007?
Provide a succinct answer. 40.36. What is the difference between the Unemployed and educated female labor force (% of population) of Hungary in 2002 and the Unemployed and educated female labor force (% of population) of Trinidad and Tobago in 2007?
Offer a very short reply. 2.7. What is the difference between the Unemployed and educated female labor force (% of population) of High income: OECD in 2002 and the Unemployed and educated female labor force (% of population) of North America in 2008?
Your answer should be very brief. -26.14. What is the difference between the Unemployed and educated female labor force (% of population) in High income: OECD in 2002 and the Unemployed and educated female labor force (% of population) in Hungary in 2008?
Provide a short and direct response. 14.32. What is the difference between the Unemployed and educated female labor force (% of population) of High income: OECD in 2002 and the Unemployed and educated female labor force (% of population) of Trinidad and Tobago in 2008?
Your response must be concise. 18.72. What is the difference between the Unemployed and educated female labor force (% of population) in North America in 2002 and the Unemployed and educated female labor force (% of population) in Hungary in 2008?
Make the answer very short. 35.86. What is the difference between the Unemployed and educated female labor force (% of population) in North America in 2002 and the Unemployed and educated female labor force (% of population) in Trinidad and Tobago in 2008?
Give a very brief answer. 40.26. What is the difference between the Unemployed and educated female labor force (% of population) of Hungary in 2002 and the Unemployed and educated female labor force (% of population) of Trinidad and Tobago in 2008?
Provide a succinct answer. 2.6. What is the difference between the Unemployed and educated female labor force (% of population) of High income: OECD in 2006 and the Unemployed and educated female labor force (% of population) of North America in 2007?
Ensure brevity in your answer.  -22.85. What is the difference between the Unemployed and educated female labor force (% of population) in High income: OECD in 2006 and the Unemployed and educated female labor force (% of population) in Hungary in 2007?
Offer a terse response. 15.71. What is the difference between the Unemployed and educated female labor force (% of population) of High income: OECD in 2006 and the Unemployed and educated female labor force (% of population) of Trinidad and Tobago in 2007?
Keep it short and to the point. 20.11. What is the difference between the Unemployed and educated female labor force (% of population) of North America in 2006 and the Unemployed and educated female labor force (% of population) of Hungary in 2007?
Keep it short and to the point. 38.37. What is the difference between the Unemployed and educated female labor force (% of population) in North America in 2006 and the Unemployed and educated female labor force (% of population) in Trinidad and Tobago in 2007?
Your answer should be compact. 42.77. What is the difference between the Unemployed and educated female labor force (% of population) of High income: OECD in 2006 and the Unemployed and educated female labor force (% of population) of North America in 2008?
Ensure brevity in your answer.  -24.85. What is the difference between the Unemployed and educated female labor force (% of population) of High income: OECD in 2006 and the Unemployed and educated female labor force (% of population) of Hungary in 2008?
Ensure brevity in your answer.  15.61. What is the difference between the Unemployed and educated female labor force (% of population) in High income: OECD in 2006 and the Unemployed and educated female labor force (% of population) in Trinidad and Tobago in 2008?
Provide a short and direct response. 20.01. What is the difference between the Unemployed and educated female labor force (% of population) of North America in 2006 and the Unemployed and educated female labor force (% of population) of Hungary in 2008?
Keep it short and to the point. 38.27. What is the difference between the Unemployed and educated female labor force (% of population) of North America in 2006 and the Unemployed and educated female labor force (% of population) of Trinidad and Tobago in 2008?
Give a very brief answer. 42.67. What is the difference between the Unemployed and educated female labor force (% of population) of Hungary in 2006 and the Unemployed and educated female labor force (% of population) of Trinidad and Tobago in 2008?
Provide a succinct answer. 2.4. What is the difference between the Unemployed and educated female labor force (% of population) of High income: OECD in 2007 and the Unemployed and educated female labor force (% of population) of North America in 2008?
Your response must be concise. -23.64. What is the difference between the Unemployed and educated female labor force (% of population) of High income: OECD in 2007 and the Unemployed and educated female labor force (% of population) of Hungary in 2008?
Give a very brief answer. 16.82. What is the difference between the Unemployed and educated female labor force (% of population) of High income: OECD in 2007 and the Unemployed and educated female labor force (% of population) of Trinidad and Tobago in 2008?
Offer a very short reply. 21.22. What is the difference between the Unemployed and educated female labor force (% of population) of North America in 2007 and the Unemployed and educated female labor force (% of population) of Hungary in 2008?
Offer a very short reply. 38.46. What is the difference between the Unemployed and educated female labor force (% of population) in North America in 2007 and the Unemployed and educated female labor force (% of population) in Trinidad and Tobago in 2008?
Offer a terse response. 42.86. What is the average Unemployed and educated female labor force (% of population) of High income: OECD per year?
Give a very brief answer. 23.55. What is the average Unemployed and educated female labor force (% of population) in North America per year?
Keep it short and to the point. 44.68. What is the average Unemployed and educated female labor force (% of population) in Hungary per year?
Keep it short and to the point. 6.51. What is the average Unemployed and educated female labor force (% of population) of Trinidad and Tobago per year?
Give a very brief answer. 2.65. In the year 1998, what is the difference between the Unemployed and educated female labor force (% of population) of High income: OECD and Unemployed and educated female labor force (% of population) of North America?
Give a very brief answer. -18.87. In the year 1998, what is the difference between the Unemployed and educated female labor force (% of population) in High income: OECD and Unemployed and educated female labor force (% of population) in Hungary?
Your answer should be very brief. 16.34. In the year 1998, what is the difference between the Unemployed and educated female labor force (% of population) in High income: OECD and Unemployed and educated female labor force (% of population) in Trinidad and Tobago?
Provide a short and direct response. 19.44. In the year 1998, what is the difference between the Unemployed and educated female labor force (% of population) of North America and Unemployed and educated female labor force (% of population) of Hungary?
Your response must be concise. 35.21. In the year 1998, what is the difference between the Unemployed and educated female labor force (% of population) in North America and Unemployed and educated female labor force (% of population) in Trinidad and Tobago?
Keep it short and to the point. 38.31. In the year 1998, what is the difference between the Unemployed and educated female labor force (% of population) in Hungary and Unemployed and educated female labor force (% of population) in Trinidad and Tobago?
Ensure brevity in your answer.  3.1. In the year 1999, what is the difference between the Unemployed and educated female labor force (% of population) of High income: OECD and Unemployed and educated female labor force (% of population) of North America?
Keep it short and to the point. -19.92. In the year 1999, what is the difference between the Unemployed and educated female labor force (% of population) of High income: OECD and Unemployed and educated female labor force (% of population) of Hungary?
Provide a short and direct response. 17.31. In the year 1999, what is the difference between the Unemployed and educated female labor force (% of population) of High income: OECD and Unemployed and educated female labor force (% of population) of Trinidad and Tobago?
Give a very brief answer. 19.61. In the year 1999, what is the difference between the Unemployed and educated female labor force (% of population) of North America and Unemployed and educated female labor force (% of population) of Hungary?
Offer a terse response. 37.23. In the year 1999, what is the difference between the Unemployed and educated female labor force (% of population) in North America and Unemployed and educated female labor force (% of population) in Trinidad and Tobago?
Provide a short and direct response. 39.53. In the year 2000, what is the difference between the Unemployed and educated female labor force (% of population) of High income: OECD and Unemployed and educated female labor force (% of population) of North America?
Give a very brief answer. -21.1. In the year 2000, what is the difference between the Unemployed and educated female labor force (% of population) in High income: OECD and Unemployed and educated female labor force (% of population) in Hungary?
Your answer should be compact. 16.12. In the year 2000, what is the difference between the Unemployed and educated female labor force (% of population) in High income: OECD and Unemployed and educated female labor force (% of population) in Trinidad and Tobago?
Provide a short and direct response. 18.62. In the year 2000, what is the difference between the Unemployed and educated female labor force (% of population) in North America and Unemployed and educated female labor force (% of population) in Hungary?
Your answer should be compact. 37.22. In the year 2000, what is the difference between the Unemployed and educated female labor force (% of population) of North America and Unemployed and educated female labor force (% of population) of Trinidad and Tobago?
Make the answer very short. 39.72. In the year 2001, what is the difference between the Unemployed and educated female labor force (% of population) of High income: OECD and Unemployed and educated female labor force (% of population) of North America?
Ensure brevity in your answer.  -22.25. In the year 2001, what is the difference between the Unemployed and educated female labor force (% of population) in High income: OECD and Unemployed and educated female labor force (% of population) in Hungary?
Give a very brief answer. 16.5. In the year 2001, what is the difference between the Unemployed and educated female labor force (% of population) in High income: OECD and Unemployed and educated female labor force (% of population) in Trinidad and Tobago?
Keep it short and to the point. 19.7. In the year 2001, what is the difference between the Unemployed and educated female labor force (% of population) in North America and Unemployed and educated female labor force (% of population) in Hungary?
Provide a succinct answer. 38.75. In the year 2001, what is the difference between the Unemployed and educated female labor force (% of population) in North America and Unemployed and educated female labor force (% of population) in Trinidad and Tobago?
Ensure brevity in your answer.  41.95. In the year 2002, what is the difference between the Unemployed and educated female labor force (% of population) of High income: OECD and Unemployed and educated female labor force (% of population) of North America?
Provide a short and direct response. -21.55. In the year 2002, what is the difference between the Unemployed and educated female labor force (% of population) of High income: OECD and Unemployed and educated female labor force (% of population) of Hungary?
Offer a very short reply. 16.12. In the year 2002, what is the difference between the Unemployed and educated female labor force (% of population) of High income: OECD and Unemployed and educated female labor force (% of population) of Trinidad and Tobago?
Ensure brevity in your answer.  22.22. In the year 2002, what is the difference between the Unemployed and educated female labor force (% of population) of North America and Unemployed and educated female labor force (% of population) of Hungary?
Give a very brief answer. 37.66. In the year 2002, what is the difference between the Unemployed and educated female labor force (% of population) of North America and Unemployed and educated female labor force (% of population) of Trinidad and Tobago?
Your response must be concise. 43.76. In the year 2006, what is the difference between the Unemployed and educated female labor force (% of population) in High income: OECD and Unemployed and educated female labor force (% of population) in North America?
Give a very brief answer. -22.66. In the year 2006, what is the difference between the Unemployed and educated female labor force (% of population) of High income: OECD and Unemployed and educated female labor force (% of population) of Hungary?
Your answer should be very brief. 17.61. In the year 2006, what is the difference between the Unemployed and educated female labor force (% of population) of High income: OECD and Unemployed and educated female labor force (% of population) of Trinidad and Tobago?
Your response must be concise. 22.51. In the year 2006, what is the difference between the Unemployed and educated female labor force (% of population) of North America and Unemployed and educated female labor force (% of population) of Hungary?
Offer a very short reply. 40.27. In the year 2006, what is the difference between the Unemployed and educated female labor force (% of population) in North America and Unemployed and educated female labor force (% of population) in Trinidad and Tobago?
Keep it short and to the point. 45.17. In the year 2006, what is the difference between the Unemployed and educated female labor force (% of population) of Hungary and Unemployed and educated female labor force (% of population) of Trinidad and Tobago?
Ensure brevity in your answer.  4.9. In the year 2007, what is the difference between the Unemployed and educated female labor force (% of population) of High income: OECD and Unemployed and educated female labor force (% of population) of North America?
Provide a short and direct response. -21.64. In the year 2007, what is the difference between the Unemployed and educated female labor force (% of population) in High income: OECD and Unemployed and educated female labor force (% of population) in Hungary?
Your response must be concise. 16.92. In the year 2007, what is the difference between the Unemployed and educated female labor force (% of population) of High income: OECD and Unemployed and educated female labor force (% of population) of Trinidad and Tobago?
Provide a short and direct response. 21.32. In the year 2007, what is the difference between the Unemployed and educated female labor force (% of population) of North America and Unemployed and educated female labor force (% of population) of Hungary?
Provide a short and direct response. 38.56. In the year 2007, what is the difference between the Unemployed and educated female labor force (% of population) of North America and Unemployed and educated female labor force (% of population) of Trinidad and Tobago?
Keep it short and to the point. 42.96. In the year 2007, what is the difference between the Unemployed and educated female labor force (% of population) in Hungary and Unemployed and educated female labor force (% of population) in Trinidad and Tobago?
Give a very brief answer. 4.4. In the year 2008, what is the difference between the Unemployed and educated female labor force (% of population) of High income: OECD and Unemployed and educated female labor force (% of population) of North America?
Offer a very short reply. -21.11. In the year 2008, what is the difference between the Unemployed and educated female labor force (% of population) of High income: OECD and Unemployed and educated female labor force (% of population) of Hungary?
Your response must be concise. 19.35. In the year 2008, what is the difference between the Unemployed and educated female labor force (% of population) of High income: OECD and Unemployed and educated female labor force (% of population) of Trinidad and Tobago?
Make the answer very short. 23.75. In the year 2008, what is the difference between the Unemployed and educated female labor force (% of population) of North America and Unemployed and educated female labor force (% of population) of Hungary?
Offer a very short reply. 40.46. In the year 2008, what is the difference between the Unemployed and educated female labor force (% of population) of North America and Unemployed and educated female labor force (% of population) of Trinidad and Tobago?
Make the answer very short. 44.86. In the year 2008, what is the difference between the Unemployed and educated female labor force (% of population) of Hungary and Unemployed and educated female labor force (% of population) of Trinidad and Tobago?
Your response must be concise. 4.4. What is the ratio of the Unemployed and educated female labor force (% of population) in High income: OECD in 1998 to that in 1999?
Ensure brevity in your answer.  0.99. What is the ratio of the Unemployed and educated female labor force (% of population) of North America in 1998 to that in 1999?
Your answer should be compact. 0.97. What is the ratio of the Unemployed and educated female labor force (% of population) in Hungary in 1998 to that in 1999?
Provide a succinct answer. 1.23. What is the ratio of the Unemployed and educated female labor force (% of population) of Trinidad and Tobago in 1998 to that in 1999?
Your answer should be compact. 0.88. What is the ratio of the Unemployed and educated female labor force (% of population) of North America in 1998 to that in 2000?
Give a very brief answer. 0.95. What is the ratio of the Unemployed and educated female labor force (% of population) in Trinidad and Tobago in 1998 to that in 2000?
Provide a short and direct response. 0.47. What is the ratio of the Unemployed and educated female labor force (% of population) of High income: OECD in 1998 to that in 2001?
Your response must be concise. 0.93. What is the ratio of the Unemployed and educated female labor force (% of population) in North America in 1998 to that in 2001?
Offer a very short reply. 0.89. What is the ratio of the Unemployed and educated female labor force (% of population) of Hungary in 1998 to that in 2001?
Your answer should be very brief. 0.75. What is the ratio of the Unemployed and educated female labor force (% of population) in Trinidad and Tobago in 1998 to that in 2001?
Keep it short and to the point. 0.37. What is the ratio of the Unemployed and educated female labor force (% of population) in High income: OECD in 1998 to that in 2002?
Make the answer very short. 0.83. What is the ratio of the Unemployed and educated female labor force (% of population) of North America in 1998 to that in 2002?
Ensure brevity in your answer.  0.85. What is the ratio of the Unemployed and educated female labor force (% of population) in Hungary in 1998 to that in 2002?
Your answer should be compact. 0.46. What is the ratio of the Unemployed and educated female labor force (% of population) of High income: OECD in 1998 to that in 2006?
Offer a terse response. 0.79. What is the ratio of the Unemployed and educated female labor force (% of population) in North America in 1998 to that in 2006?
Your answer should be compact. 0.81. What is the ratio of the Unemployed and educated female labor force (% of population) in Hungary in 1998 to that in 2006?
Offer a terse response. 0.47. What is the ratio of the Unemployed and educated female labor force (% of population) of Trinidad and Tobago in 1998 to that in 2006?
Your answer should be very brief. 0.23. What is the ratio of the Unemployed and educated female labor force (% of population) of High income: OECD in 1998 to that in 2007?
Offer a very short reply. 0.75. What is the ratio of the Unemployed and educated female labor force (% of population) of North America in 1998 to that in 2007?
Your answer should be compact. 0.81. What is the ratio of the Unemployed and educated female labor force (% of population) of Hungary in 1998 to that in 2007?
Offer a terse response. 0.38. What is the ratio of the Unemployed and educated female labor force (% of population) in Trinidad and Tobago in 1998 to that in 2007?
Your response must be concise. 0.13. What is the ratio of the Unemployed and educated female labor force (% of population) of High income: OECD in 1998 to that in 2008?
Offer a very short reply. 0.69. What is the ratio of the Unemployed and educated female labor force (% of population) in North America in 1998 to that in 2008?
Your answer should be compact. 0.77. What is the ratio of the Unemployed and educated female labor force (% of population) of Hungary in 1998 to that in 2008?
Your answer should be very brief. 0.38. What is the ratio of the Unemployed and educated female labor force (% of population) of High income: OECD in 1999 to that in 2000?
Your response must be concise. 1.01. What is the ratio of the Unemployed and educated female labor force (% of population) in North America in 1999 to that in 2000?
Your answer should be compact. 0.98. What is the ratio of the Unemployed and educated female labor force (% of population) in Hungary in 1999 to that in 2000?
Offer a very short reply. 0.78. What is the ratio of the Unemployed and educated female labor force (% of population) in Trinidad and Tobago in 1999 to that in 2000?
Make the answer very short. 0.53. What is the ratio of the Unemployed and educated female labor force (% of population) of High income: OECD in 1999 to that in 2001?
Give a very brief answer. 0.94. What is the ratio of the Unemployed and educated female labor force (% of population) of North America in 1999 to that in 2001?
Your answer should be compact. 0.92. What is the ratio of the Unemployed and educated female labor force (% of population) of Hungary in 1999 to that in 2001?
Provide a succinct answer. 0.61. What is the ratio of the Unemployed and educated female labor force (% of population) in Trinidad and Tobago in 1999 to that in 2001?
Ensure brevity in your answer.  0.42. What is the ratio of the Unemployed and educated female labor force (% of population) in High income: OECD in 1999 to that in 2002?
Ensure brevity in your answer.  0.84. What is the ratio of the Unemployed and educated female labor force (% of population) in North America in 1999 to that in 2002?
Ensure brevity in your answer.  0.88. What is the ratio of the Unemployed and educated female labor force (% of population) in Hungary in 1999 to that in 2002?
Your answer should be compact. 0.38. What is the ratio of the Unemployed and educated female labor force (% of population) in Trinidad and Tobago in 1999 to that in 2002?
Offer a very short reply. 0.38. What is the ratio of the Unemployed and educated female labor force (% of population) in High income: OECD in 1999 to that in 2006?
Your response must be concise. 0.8. What is the ratio of the Unemployed and educated female labor force (% of population) in North America in 1999 to that in 2006?
Ensure brevity in your answer.  0.84. What is the ratio of the Unemployed and educated female labor force (% of population) of Hungary in 1999 to that in 2006?
Your response must be concise. 0.39. What is the ratio of the Unemployed and educated female labor force (% of population) of Trinidad and Tobago in 1999 to that in 2006?
Offer a terse response. 0.26. What is the ratio of the Unemployed and educated female labor force (% of population) of High income: OECD in 1999 to that in 2007?
Give a very brief answer. 0.76. What is the ratio of the Unemployed and educated female labor force (% of population) of North America in 1999 to that in 2007?
Ensure brevity in your answer.  0.83. What is the ratio of the Unemployed and educated female labor force (% of population) in Hungary in 1999 to that in 2007?
Provide a succinct answer. 0.31. What is the ratio of the Unemployed and educated female labor force (% of population) in Trinidad and Tobago in 1999 to that in 2007?
Your answer should be compact. 0.15. What is the ratio of the Unemployed and educated female labor force (% of population) in High income: OECD in 1999 to that in 2008?
Offer a terse response. 0.7. What is the ratio of the Unemployed and educated female labor force (% of population) of North America in 1999 to that in 2008?
Offer a very short reply. 0.8. What is the ratio of the Unemployed and educated female labor force (% of population) in Hungary in 1999 to that in 2008?
Provide a succinct answer. 0.31. What is the ratio of the Unemployed and educated female labor force (% of population) in Trinidad and Tobago in 1999 to that in 2008?
Keep it short and to the point. 0.14. What is the ratio of the Unemployed and educated female labor force (% of population) of High income: OECD in 2000 to that in 2001?
Offer a terse response. 0.93. What is the ratio of the Unemployed and educated female labor force (% of population) of Hungary in 2000 to that in 2001?
Your answer should be very brief. 0.78. What is the ratio of the Unemployed and educated female labor force (% of population) of Trinidad and Tobago in 2000 to that in 2001?
Offer a very short reply. 0.79. What is the ratio of the Unemployed and educated female labor force (% of population) in High income: OECD in 2000 to that in 2002?
Keep it short and to the point. 0.83. What is the ratio of the Unemployed and educated female labor force (% of population) in North America in 2000 to that in 2002?
Your answer should be compact. 0.9. What is the ratio of the Unemployed and educated female labor force (% of population) of Hungary in 2000 to that in 2002?
Provide a short and direct response. 0.49. What is the ratio of the Unemployed and educated female labor force (% of population) in High income: OECD in 2000 to that in 2006?
Give a very brief answer. 0.79. What is the ratio of the Unemployed and educated female labor force (% of population) in North America in 2000 to that in 2006?
Make the answer very short. 0.85. What is the ratio of the Unemployed and educated female labor force (% of population) in Trinidad and Tobago in 2000 to that in 2006?
Provide a succinct answer. 0.48. What is the ratio of the Unemployed and educated female labor force (% of population) in North America in 2000 to that in 2007?
Offer a very short reply. 0.85. What is the ratio of the Unemployed and educated female labor force (% of population) in Hungary in 2000 to that in 2007?
Offer a terse response. 0.4. What is the ratio of the Unemployed and educated female labor force (% of population) of Trinidad and Tobago in 2000 to that in 2007?
Provide a short and direct response. 0.27. What is the ratio of the Unemployed and educated female labor force (% of population) in High income: OECD in 2000 to that in 2008?
Make the answer very short. 0.69. What is the ratio of the Unemployed and educated female labor force (% of population) in North America in 2000 to that in 2008?
Offer a very short reply. 0.82. What is the ratio of the Unemployed and educated female labor force (% of population) in Hungary in 2000 to that in 2008?
Keep it short and to the point. 0.4. What is the ratio of the Unemployed and educated female labor force (% of population) of Trinidad and Tobago in 2000 to that in 2008?
Offer a very short reply. 0.27. What is the ratio of the Unemployed and educated female labor force (% of population) of High income: OECD in 2001 to that in 2002?
Provide a succinct answer. 0.89. What is the ratio of the Unemployed and educated female labor force (% of population) of North America in 2001 to that in 2002?
Your answer should be compact. 0.96. What is the ratio of the Unemployed and educated female labor force (% of population) of Hungary in 2001 to that in 2002?
Provide a short and direct response. 0.62. What is the ratio of the Unemployed and educated female labor force (% of population) of Trinidad and Tobago in 2001 to that in 2002?
Give a very brief answer. 0.9. What is the ratio of the Unemployed and educated female labor force (% of population) of High income: OECD in 2001 to that in 2006?
Ensure brevity in your answer.  0.84. What is the ratio of the Unemployed and educated female labor force (% of population) in North America in 2001 to that in 2006?
Provide a short and direct response. 0.91. What is the ratio of the Unemployed and educated female labor force (% of population) of Hungary in 2001 to that in 2006?
Offer a terse response. 0.64. What is the ratio of the Unemployed and educated female labor force (% of population) of Trinidad and Tobago in 2001 to that in 2006?
Make the answer very short. 0.61. What is the ratio of the Unemployed and educated female labor force (% of population) of High income: OECD in 2001 to that in 2007?
Offer a very short reply. 0.81. What is the ratio of the Unemployed and educated female labor force (% of population) of North America in 2001 to that in 2007?
Offer a terse response. 0.9. What is the ratio of the Unemployed and educated female labor force (% of population) of Hungary in 2001 to that in 2007?
Your answer should be compact. 0.52. What is the ratio of the Unemployed and educated female labor force (% of population) of Trinidad and Tobago in 2001 to that in 2007?
Provide a short and direct response. 0.35. What is the ratio of the Unemployed and educated female labor force (% of population) in High income: OECD in 2001 to that in 2008?
Your answer should be compact. 0.74. What is the ratio of the Unemployed and educated female labor force (% of population) in North America in 2001 to that in 2008?
Give a very brief answer. 0.87. What is the ratio of the Unemployed and educated female labor force (% of population) of Hungary in 2001 to that in 2008?
Ensure brevity in your answer.  0.51. What is the ratio of the Unemployed and educated female labor force (% of population) of Trinidad and Tobago in 2001 to that in 2008?
Provide a short and direct response. 0.34. What is the ratio of the Unemployed and educated female labor force (% of population) of High income: OECD in 2002 to that in 2006?
Provide a short and direct response. 0.95. What is the ratio of the Unemployed and educated female labor force (% of population) of North America in 2002 to that in 2006?
Your answer should be compact. 0.95. What is the ratio of the Unemployed and educated female labor force (% of population) in Hungary in 2002 to that in 2006?
Ensure brevity in your answer.  1.02. What is the ratio of the Unemployed and educated female labor force (% of population) in Trinidad and Tobago in 2002 to that in 2006?
Give a very brief answer. 0.68. What is the ratio of the Unemployed and educated female labor force (% of population) in High income: OECD in 2002 to that in 2007?
Provide a short and direct response. 0.91. What is the ratio of the Unemployed and educated female labor force (% of population) in North America in 2002 to that in 2007?
Your answer should be compact. 0.95. What is the ratio of the Unemployed and educated female labor force (% of population) of Hungary in 2002 to that in 2007?
Your answer should be compact. 0.83. What is the ratio of the Unemployed and educated female labor force (% of population) of Trinidad and Tobago in 2002 to that in 2007?
Offer a very short reply. 0.38. What is the ratio of the Unemployed and educated female labor force (% of population) of High income: OECD in 2002 to that in 2008?
Your answer should be compact. 0.83. What is the ratio of the Unemployed and educated female labor force (% of population) of North America in 2002 to that in 2008?
Keep it short and to the point. 0.91. What is the ratio of the Unemployed and educated female labor force (% of population) in Hungary in 2002 to that in 2008?
Give a very brief answer. 0.82. What is the ratio of the Unemployed and educated female labor force (% of population) of Trinidad and Tobago in 2002 to that in 2008?
Offer a very short reply. 0.38. What is the ratio of the Unemployed and educated female labor force (% of population) of High income: OECD in 2006 to that in 2007?
Offer a terse response. 0.95. What is the ratio of the Unemployed and educated female labor force (% of population) of Hungary in 2006 to that in 2007?
Your answer should be compact. 0.81. What is the ratio of the Unemployed and educated female labor force (% of population) in Trinidad and Tobago in 2006 to that in 2007?
Keep it short and to the point. 0.56. What is the ratio of the Unemployed and educated female labor force (% of population) of High income: OECD in 2006 to that in 2008?
Offer a very short reply. 0.87. What is the ratio of the Unemployed and educated female labor force (% of population) of North America in 2006 to that in 2008?
Your answer should be compact. 0.96. What is the ratio of the Unemployed and educated female labor force (% of population) of Hungary in 2006 to that in 2008?
Make the answer very short. 0.8. What is the ratio of the Unemployed and educated female labor force (% of population) in Trinidad and Tobago in 2006 to that in 2008?
Your response must be concise. 0.55. What is the ratio of the Unemployed and educated female labor force (% of population) in High income: OECD in 2007 to that in 2008?
Your response must be concise. 0.91. What is the ratio of the Unemployed and educated female labor force (% of population) in North America in 2007 to that in 2008?
Ensure brevity in your answer.  0.96. What is the ratio of the Unemployed and educated female labor force (% of population) in Hungary in 2007 to that in 2008?
Provide a succinct answer. 0.99. What is the ratio of the Unemployed and educated female labor force (% of population) of Trinidad and Tobago in 2007 to that in 2008?
Your answer should be very brief. 0.98. What is the difference between the highest and the second highest Unemployed and educated female labor force (% of population) of High income: OECD?
Make the answer very short. 2.53. What is the difference between the highest and the second highest Unemployed and educated female labor force (% of population) in North America?
Keep it short and to the point. 2. What is the difference between the highest and the lowest Unemployed and educated female labor force (% of population) of High income: OECD?
Your answer should be very brief. 9.24. What is the difference between the highest and the lowest Unemployed and educated female labor force (% of population) of North America?
Keep it short and to the point. 11.45. 